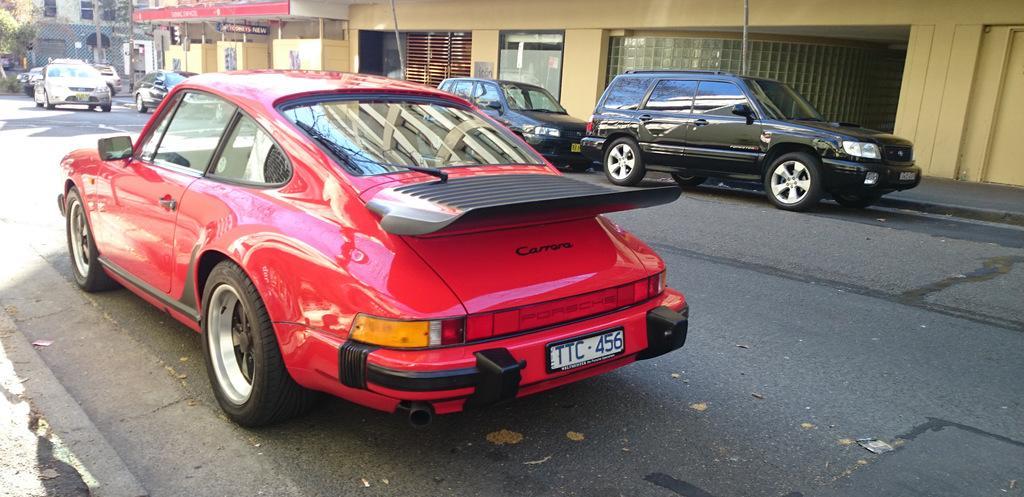How would you summarize this image in a sentence or two? There are cars in the foreground area of the image, there are buildings, posters, trees and vehicles in the background area. 